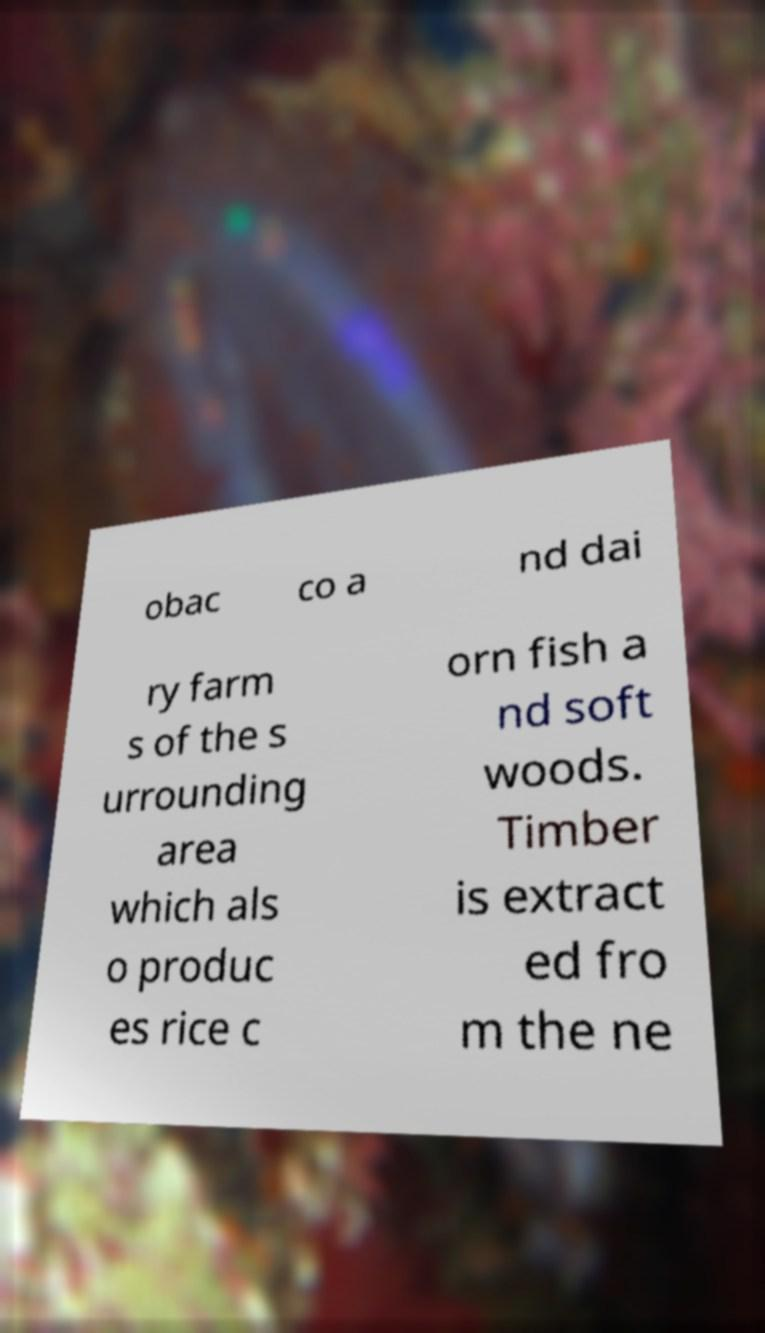Could you extract and type out the text from this image? obac co a nd dai ry farm s of the s urrounding area which als o produc es rice c orn fish a nd soft woods. Timber is extract ed fro m the ne 